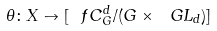<formula> <loc_0><loc_0><loc_500><loc_500>\theta \colon X \to [ \ f C _ { G } ^ { d } / ( G \times \ G L _ { d } ) ]</formula> 